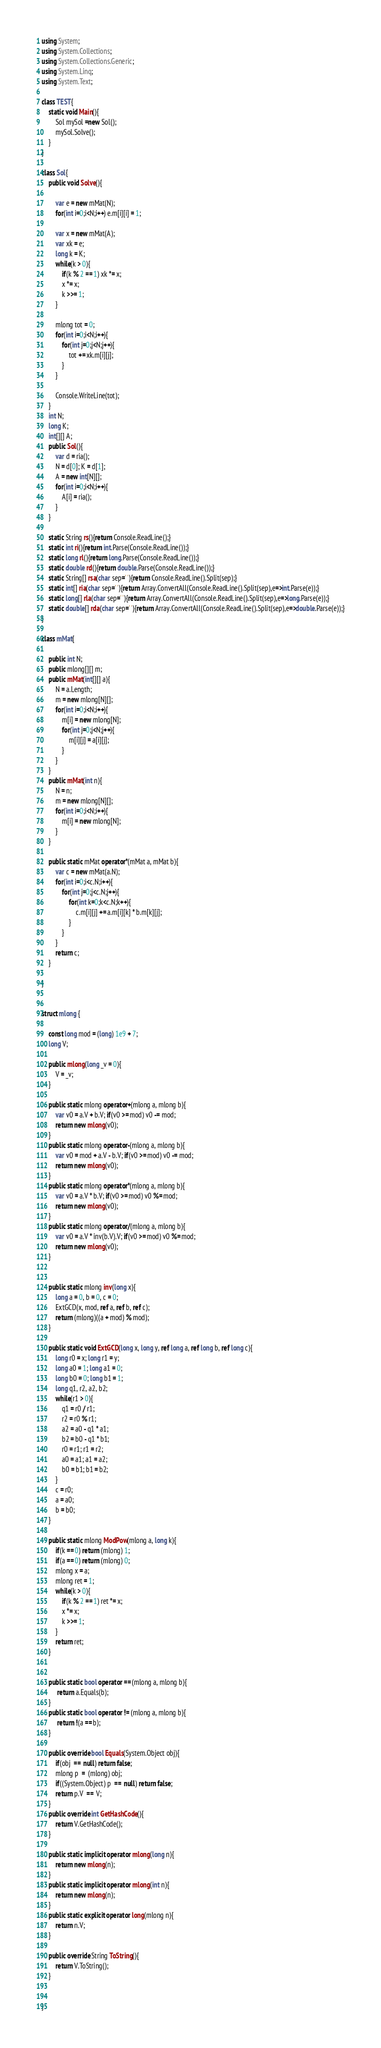<code> <loc_0><loc_0><loc_500><loc_500><_C#_>using System;
using System.Collections;
using System.Collections.Generic;
using System.Linq;
using System.Text;

class TEST{
	static void Main(){
		Sol mySol =new Sol();
		mySol.Solve();
	}
}

class Sol{
	public void Solve(){
		
		var e = new mMat(N);
		for(int i=0;i<N;i++) e.m[i][i] = 1;
		
		var x = new mMat(A);
		var xk = e;
		long k = K;
		while(k > 0){
			if(k % 2 == 1) xk *= x;
			x *= x;
			k >>= 1;
		}
		
		mlong tot = 0;
		for(int i=0;i<N;i++){
			for(int j=0;j<N;j++){
				tot += xk.m[i][j];
			}
		}
		
		Console.WriteLine(tot);
	}
	int N;
	long K;
	int[][] A;
	public Sol(){
		var d = ria();
		N = d[0]; K = d[1];
		A = new int[N][];
		for(int i=0;i<N;i++){
			A[i] = ria();
		}
	}

	static String rs(){return Console.ReadLine();}
	static int ri(){return int.Parse(Console.ReadLine());}
	static long rl(){return long.Parse(Console.ReadLine());}
	static double rd(){return double.Parse(Console.ReadLine());}
	static String[] rsa(char sep=' '){return Console.ReadLine().Split(sep);}
	static int[] ria(char sep=' '){return Array.ConvertAll(Console.ReadLine().Split(sep),e=>int.Parse(e));}
	static long[] rla(char sep=' '){return Array.ConvertAll(Console.ReadLine().Split(sep),e=>long.Parse(e));}
	static double[] rda(char sep=' '){return Array.ConvertAll(Console.ReadLine().Split(sep),e=>double.Parse(e));}
}

class mMat{
	
	public int N;
	public mlong[][] m;
	public mMat(int[][] a){
		N = a.Length;
		m = new mlong[N][];
		for(int i=0;i<N;i++){
			m[i] = new mlong[N];
			for(int j=0;j<N;j++){
				m[i][j] = a[i][j];
			}
		}
	}
	public mMat(int n){
		N = n;
		m = new mlong[N][];
		for(int i=0;i<N;i++){
			m[i] = new mlong[N];
		}
	}
	
	public static mMat operator*(mMat a, mMat b){
		var c = new mMat(a.N);
		for(int i=0;i<c.N;i++){
			for(int j=0;j<c.N;j++){
				for(int k=0;k<c.N;k++){
					c.m[i][j] += a.m[i][k] * b.m[k][j];
				}
			}
		}
		return c;
	}
	
}


struct mlong {
	
	const long mod = (long) 1e9 + 7;
	long V;
	
	public mlong(long _v = 0){
		V = _v;
	}
	
	public static mlong operator+(mlong a, mlong b){
		var v0 = a.V + b.V; if(v0 >= mod) v0 -= mod;
		return new mlong(v0);
	}
	public static mlong operator-(mlong a, mlong b){
		var v0 = mod + a.V - b.V; if(v0 >= mod) v0 -= mod;
		return new mlong(v0);
	}
	public static mlong operator*(mlong a, mlong b){
		var v0 = a.V * b.V; if(v0 >= mod) v0 %= mod;
		return new mlong(v0);
	}
	public static mlong operator/(mlong a, mlong b){
		var v0 = a.V * inv(b.V).V; if(v0 >= mod) v0 %= mod;
		return new mlong(v0);
	}
	
	
	public static mlong inv(long x){
		long a = 0, b = 0, c = 0;
		ExtGCD(x, mod, ref a, ref b, ref c);
		return (mlong)((a + mod) % mod);
	}
	
	public static void ExtGCD(long x, long y, ref long a, ref long b, ref long c){
		long r0 = x; long r1 = y;
		long a0 = 1; long a1 = 0;
		long b0 = 0; long b1 = 1;
		long q1, r2, a2, b2;
		while(r1 > 0){
			q1 = r0 / r1;
			r2 = r0 % r1;
			a2 = a0 - q1 * a1;
			b2 = b0 - q1 * b1;
			r0 = r1; r1 = r2;
			a0 = a1; a1 = a2;
			b0 = b1; b1 = b2;
		}
		c = r0;
		a = a0;
		b = b0;
	}
	
	public static mlong ModPow(mlong a, long k){
		if(k == 0) return (mlong) 1;
		if(a == 0) return (mlong) 0;
		mlong x = a;
		mlong ret = 1;
		while(k > 0){
			if(k % 2 == 1) ret *= x;
			x *= x;
			k >>= 1;
		}
		return ret;
	}
	
	
	public static bool operator == (mlong a, mlong b){
		 return a.Equals(b);
	}
	public static bool operator != (mlong a, mlong b){
		 return !(a == b);
	}
	
	public override bool Equals(System.Object obj){
		if(obj  ==  null) return false;
		mlong p  =  (mlong) obj;
		if((System.Object) p  ==  null) return false;
		return p.V  ==  V;
	}
	public override int GetHashCode(){
		return V.GetHashCode();
	}
	
	public static implicit operator mlong(long n){
		return new mlong(n);
	}
	public static implicit operator mlong(int n){
		return new mlong(n);
	}
	public static explicit operator long(mlong n){
		return n.V;
	}
	
	public override String ToString(){
		return V.ToString();
	}
	
	
}</code> 